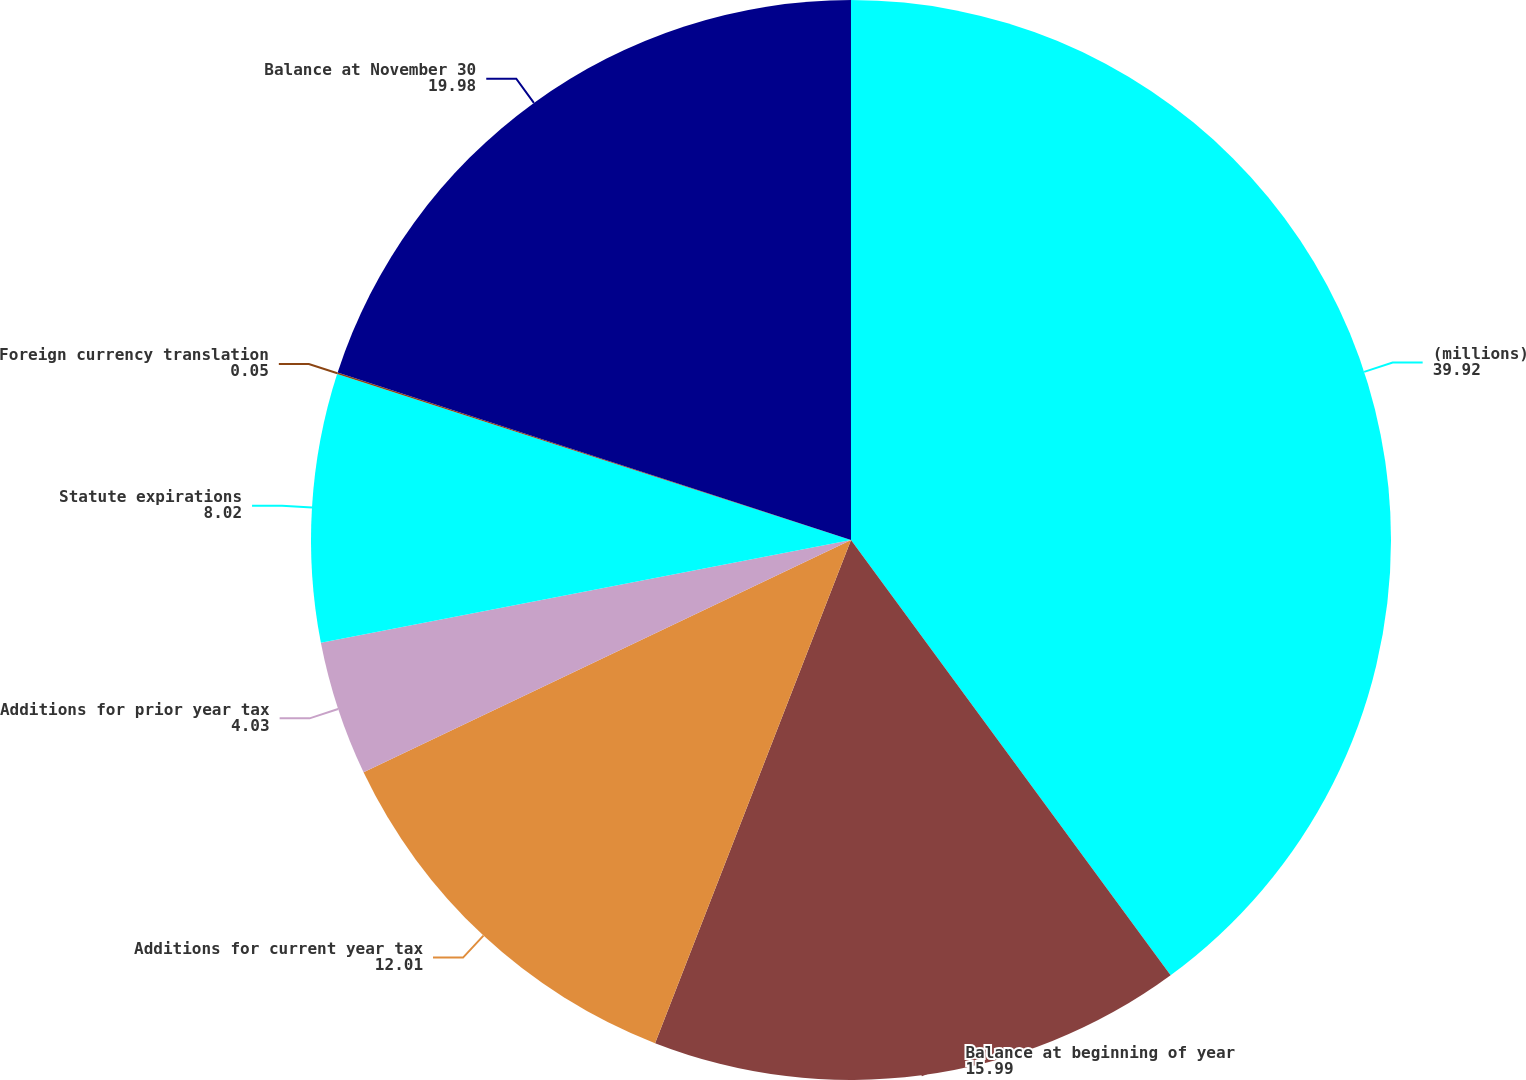Convert chart. <chart><loc_0><loc_0><loc_500><loc_500><pie_chart><fcel>(millions)<fcel>Balance at beginning of year<fcel>Additions for current year tax<fcel>Additions for prior year tax<fcel>Statute expirations<fcel>Foreign currency translation<fcel>Balance at November 30<nl><fcel>39.92%<fcel>15.99%<fcel>12.01%<fcel>4.03%<fcel>8.02%<fcel>0.05%<fcel>19.98%<nl></chart> 